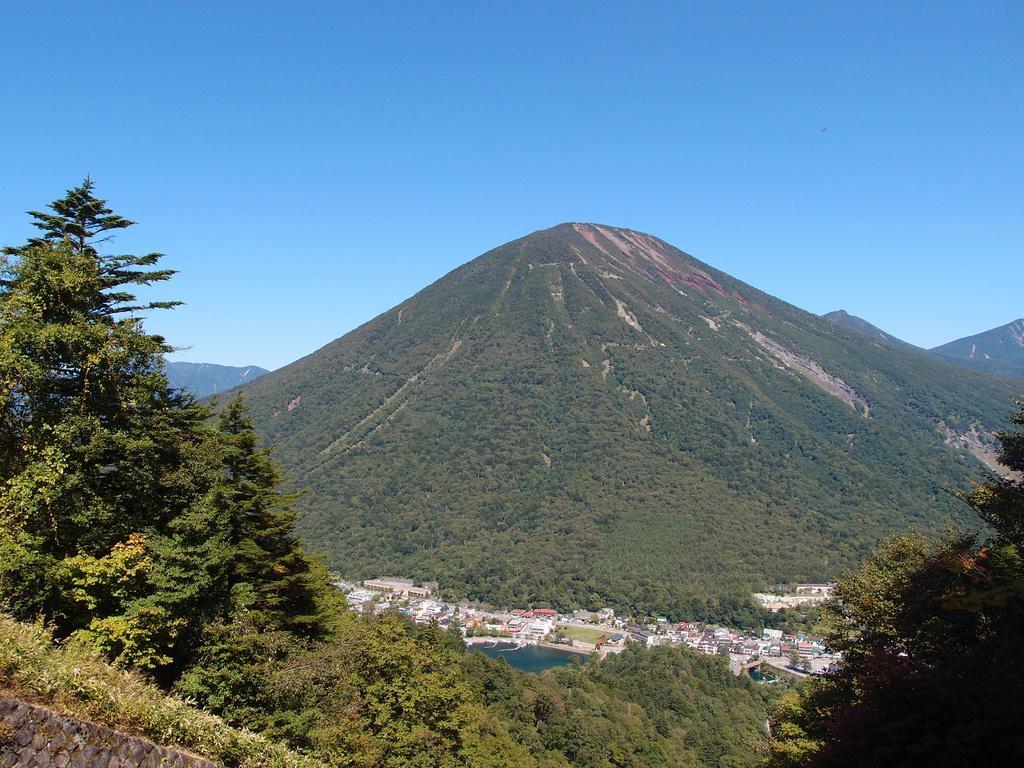Please provide a concise description of this image. In this image we can see some trees and plants and we can see some buildings and the water body in the middle of the image. We can see the mountains in the background and the sky at the top. 